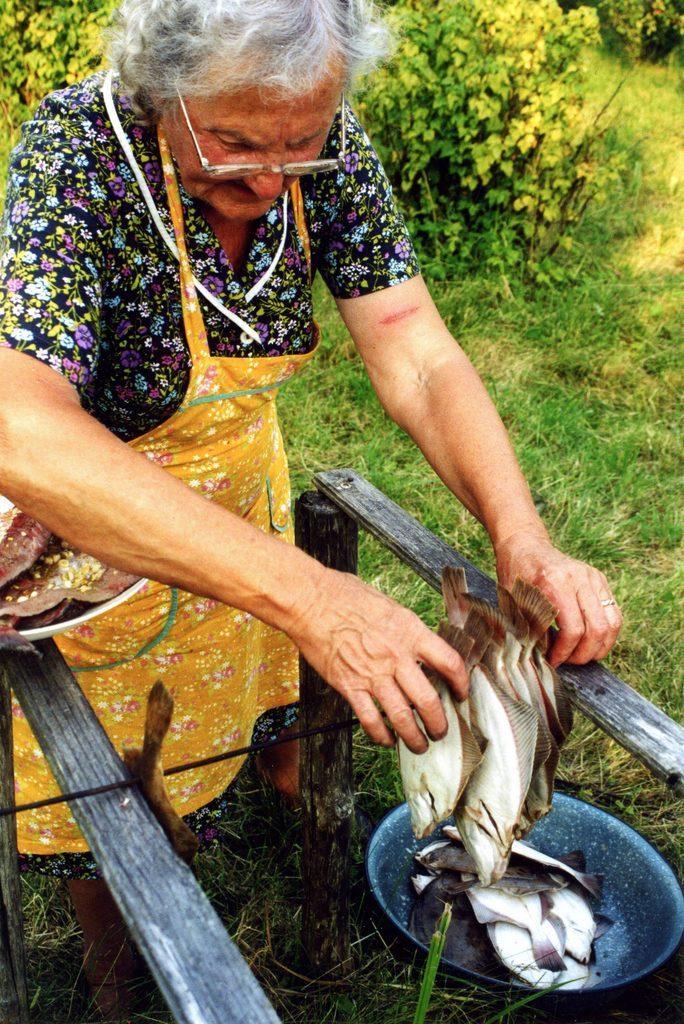Can you describe this image briefly? In this image, we can see a lady wearing glasses and a coat and placing fish on the skewer and there is a plate and a bowl containing fish. In the background, there are plants. At the bottom, there is ground. 